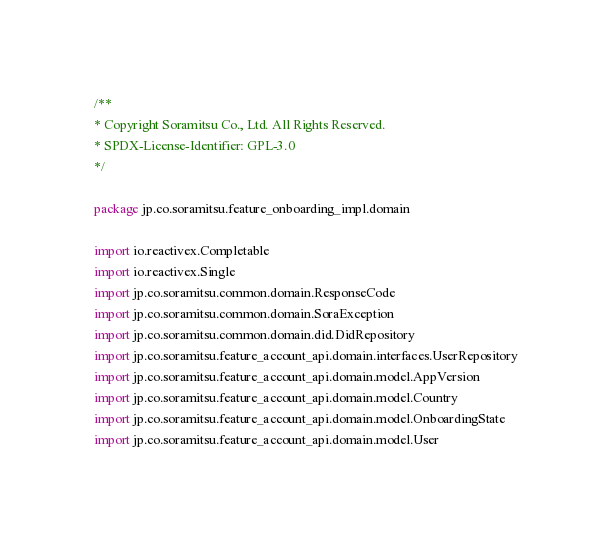<code> <loc_0><loc_0><loc_500><loc_500><_Kotlin_>/**
* Copyright Soramitsu Co., Ltd. All Rights Reserved.
* SPDX-License-Identifier: GPL-3.0
*/

package jp.co.soramitsu.feature_onboarding_impl.domain

import io.reactivex.Completable
import io.reactivex.Single
import jp.co.soramitsu.common.domain.ResponseCode
import jp.co.soramitsu.common.domain.SoraException
import jp.co.soramitsu.common.domain.did.DidRepository
import jp.co.soramitsu.feature_account_api.domain.interfaces.UserRepository
import jp.co.soramitsu.feature_account_api.domain.model.AppVersion
import jp.co.soramitsu.feature_account_api.domain.model.Country
import jp.co.soramitsu.feature_account_api.domain.model.OnboardingState
import jp.co.soramitsu.feature_account_api.domain.model.User</code> 